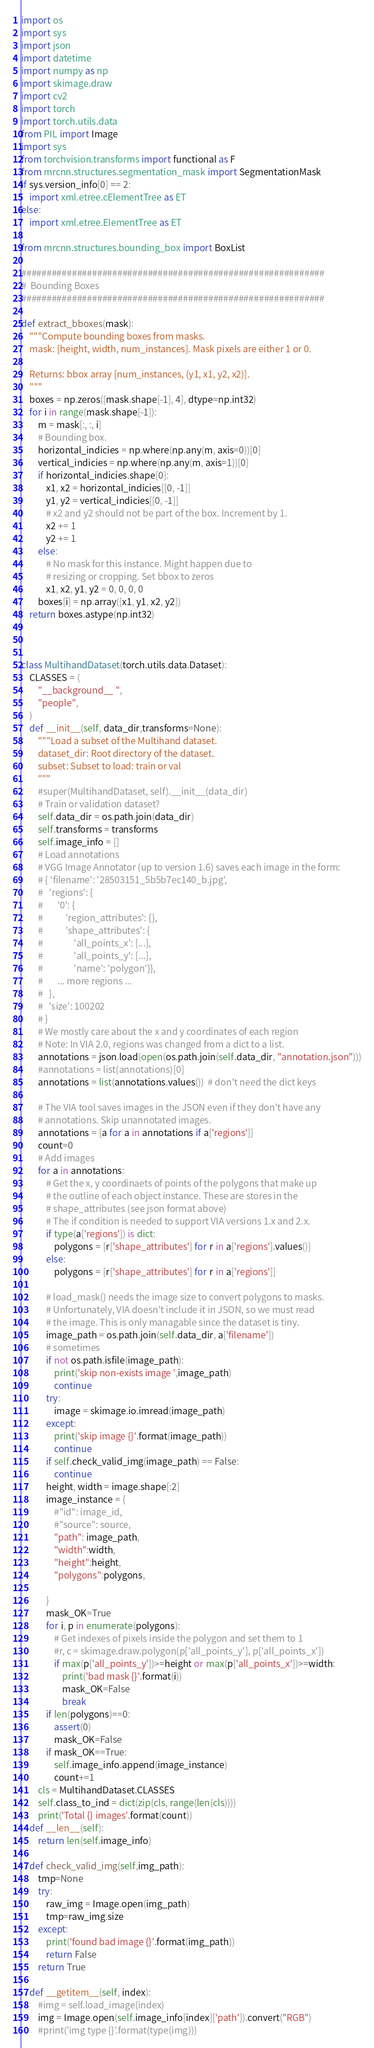Convert code to text. <code><loc_0><loc_0><loc_500><loc_500><_Python_>import os
import sys
import json
import datetime
import numpy as np
import skimage.draw
import cv2
import torch
import torch.utils.data
from PIL import Image
import sys
from torchvision.transforms import functional as F
from mrcnn.structures.segmentation_mask import SegmentationMask
if sys.version_info[0] == 2:
    import xml.etree.cElementTree as ET
else:
    import xml.etree.ElementTree as ET

from mrcnn.structures.bounding_box import BoxList

############################################################
#  Bounding Boxes
############################################################

def extract_bboxes(mask):
    """Compute bounding boxes from masks.
    mask: [height, width, num_instances]. Mask pixels are either 1 or 0.

    Returns: bbox array [num_instances, (y1, x1, y2, x2)].
    """
    boxes = np.zeros([mask.shape[-1], 4], dtype=np.int32)
    for i in range(mask.shape[-1]):
        m = mask[:, :, i]
        # Bounding box.
        horizontal_indicies = np.where(np.any(m, axis=0))[0]
        vertical_indicies = np.where(np.any(m, axis=1))[0]
        if horizontal_indicies.shape[0]:
            x1, x2 = horizontal_indicies[[0, -1]]
            y1, y2 = vertical_indicies[[0, -1]]
            # x2 and y2 should not be part of the box. Increment by 1.
            x2 += 1
            y2 += 1
        else:
            # No mask for this instance. Might happen due to
            # resizing or cropping. Set bbox to zeros
            x1, x2, y1, y2 = 0, 0, 0, 0
        boxes[i] = np.array([x1, y1, x2, y2])
    return boxes.astype(np.int32)



class MultihandDataset(torch.utils.data.Dataset):
    CLASSES = (
        "__background__ ",
        "people",
    )
    def __init__(self, data_dir,transforms=None):
        """Load a subset of the Multihand dataset.
        dataset_dir: Root directory of the dataset.
        subset: Subset to load: train or val
        """
        #super(MultihandDataset, self).__init__(data_dir)
        # Train or validation dataset?
        self.data_dir = os.path.join(data_dir)
        self.transforms = transforms
        self.image_info = []
        # Load annotations
        # VGG Image Annotator (up to version 1.6) saves each image in the form:
        # { 'filename': '28503151_5b5b7ec140_b.jpg',
        #   'regions': {
        #       '0': {
        #           'region_attributes': {},
        #           'shape_attributes': {
        #               'all_points_x': [...],
        #               'all_points_y': [...],
        #               'name': 'polygon'}},
        #       ... more regions ...
        #   },
        #   'size': 100202
        # }
        # We mostly care about the x and y coordinates of each region
        # Note: In VIA 2.0, regions was changed from a dict to a list.
        annotations = json.load(open(os.path.join(self.data_dir, "annotation.json")))
        #annotations = list(annotations)[0]
        annotations = list(annotations.values())  # don't need the dict keys

        # The VIA tool saves images in the JSON even if they don't have any
        # annotations. Skip unannotated images.
        annotations = [a for a in annotations if a['regions']]
        count=0
        # Add images
        for a in annotations:
            # Get the x, y coordinaets of points of the polygons that make up
            # the outline of each object instance. These are stores in the
            # shape_attributes (see json format above)
            # The if condition is needed to support VIA versions 1.x and 2.x.
            if type(a['regions']) is dict:
                polygons = [r['shape_attributes'] for r in a['regions'].values()]
            else:
                polygons = [r['shape_attributes'] for r in a['regions']] 

            # load_mask() needs the image size to convert polygons to masks.
            # Unfortunately, VIA doesn't include it in JSON, so we must read
            # the image. This is only managable since the dataset is tiny.
            image_path = os.path.join(self.data_dir, a['filename'])
            # sometimes
            if not os.path.isfile(image_path):
                print('skip non-exists image ',image_path)
                continue
            try:
                image = skimage.io.imread(image_path)
            except:
                print('skip image {}'.format(image_path))
                continue
            if self.check_valid_img(image_path) == False:
                continue
            height, width = image.shape[:2]
            image_instance = {
                #"id": image_id,
                #"source": source,
                "path": image_path,
                "width":width,
                "height":height,
                "polygons":polygons,
                
            }
            mask_OK=True
            for i, p in enumerate(polygons):
                # Get indexes of pixels inside the polygon and set them to 1
                #r, c = skimage.draw.polygon(p['all_points_y'], p['all_points_x'])
                if max(p['all_points_y'])>=height or max(p['all_points_x'])>=width:
                    print('bad mask {}'.format(i))
                    mask_OK=False
                    break
            if len(polygons)==0:
                assert(0)
                mask_OK=False
            if mask_OK==True:
                self.image_info.append(image_instance)
                count+=1
        cls = MultihandDataset.CLASSES
        self.class_to_ind = dict(zip(cls, range(len(cls))))
        print('Total {} images'.format(count))        
    def __len__(self):
        return len(self.image_info)

    def check_valid_img(self,img_path):
        tmp=None
        try:
            raw_img = Image.open(img_path)
            tmp=raw_img.size
        except:
            print('found bad image {}'.format(img_path))
            return False
        return True
        
    def __getitem__(self, index):
        #img = self.load_image(index)
        img = Image.open(self.image_info[index]['path']).convert("RGB")
        #print('img type {}'.format(type(img)))</code> 